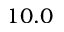Convert formula to latex. <formula><loc_0><loc_0><loc_500><loc_500>1 0 . 0</formula> 